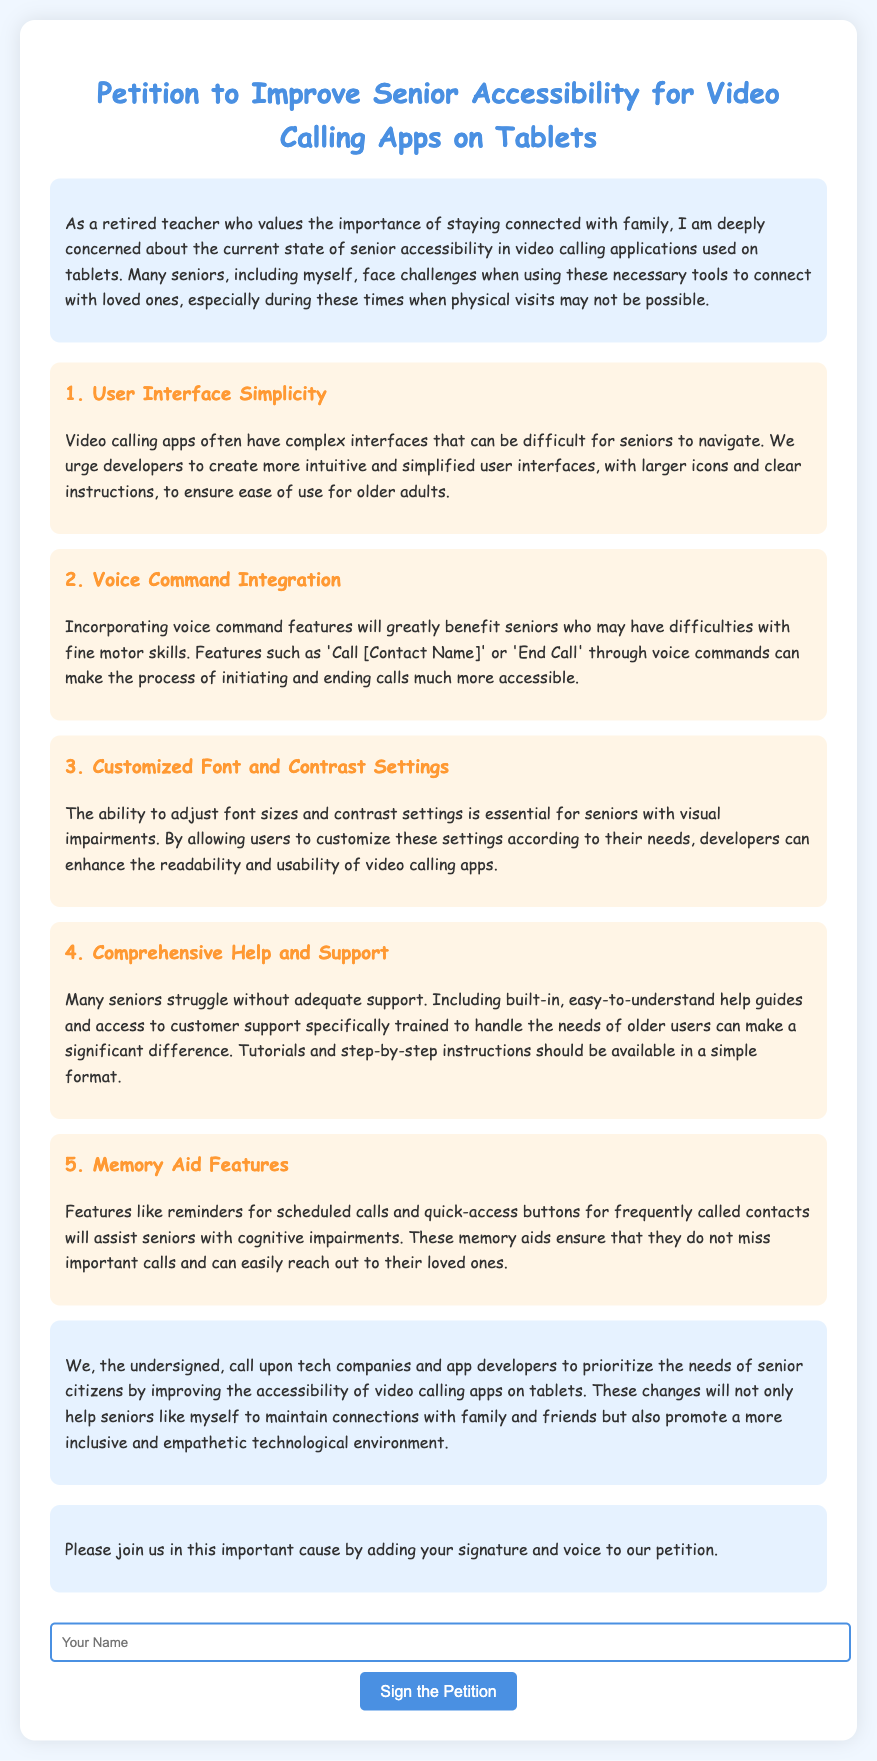What is the title of the petition? The title of the petition is stated at the top of the document, emphasizing the purpose of improving senior accessibility.
Answer: Petition to Improve Senior Accessibility for Video Calling Apps on Tablets How many main points are outlined in the petition? The main points are clearly numbered in the document, leading to a specific count of the outlined suggestions.
Answer: 5 What feature is suggested for enhancing user experience in video calling apps? The petition lists several enhancements, one of which relates to simplifying the user interface for better accessibility.
Answer: User Interface Simplicity What is a proposed benefit of voice command integration? The document describes how this feature would assist seniors with specific difficulties, providing a clear rationale for its inclusion.
Answer: Difficulties with fine motor skills What type of support is emphasized in the petition for seniors? The petition highlights the need for adequate support, specifically mentioning the importance of easily understandable help guides.
Answer: Comprehensive Help and Support Who is the petition aimed at? The document directly addresses key stakeholders who have the power to implement the suggested improvements.
Answer: Tech companies and app developers What is a memory aid feature mentioned in the petition? The document provides a specific example of a feature designed to assist seniors in remembering key actions related to calling.
Answer: Reminders for scheduled calls What is the color scheme of the document? The document has a specified style and design which reflects a calm and inviting color scheme, as stated in the page's CSS.
Answer: Blue and white 